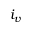<formula> <loc_0><loc_0><loc_500><loc_500>i _ { v }</formula> 